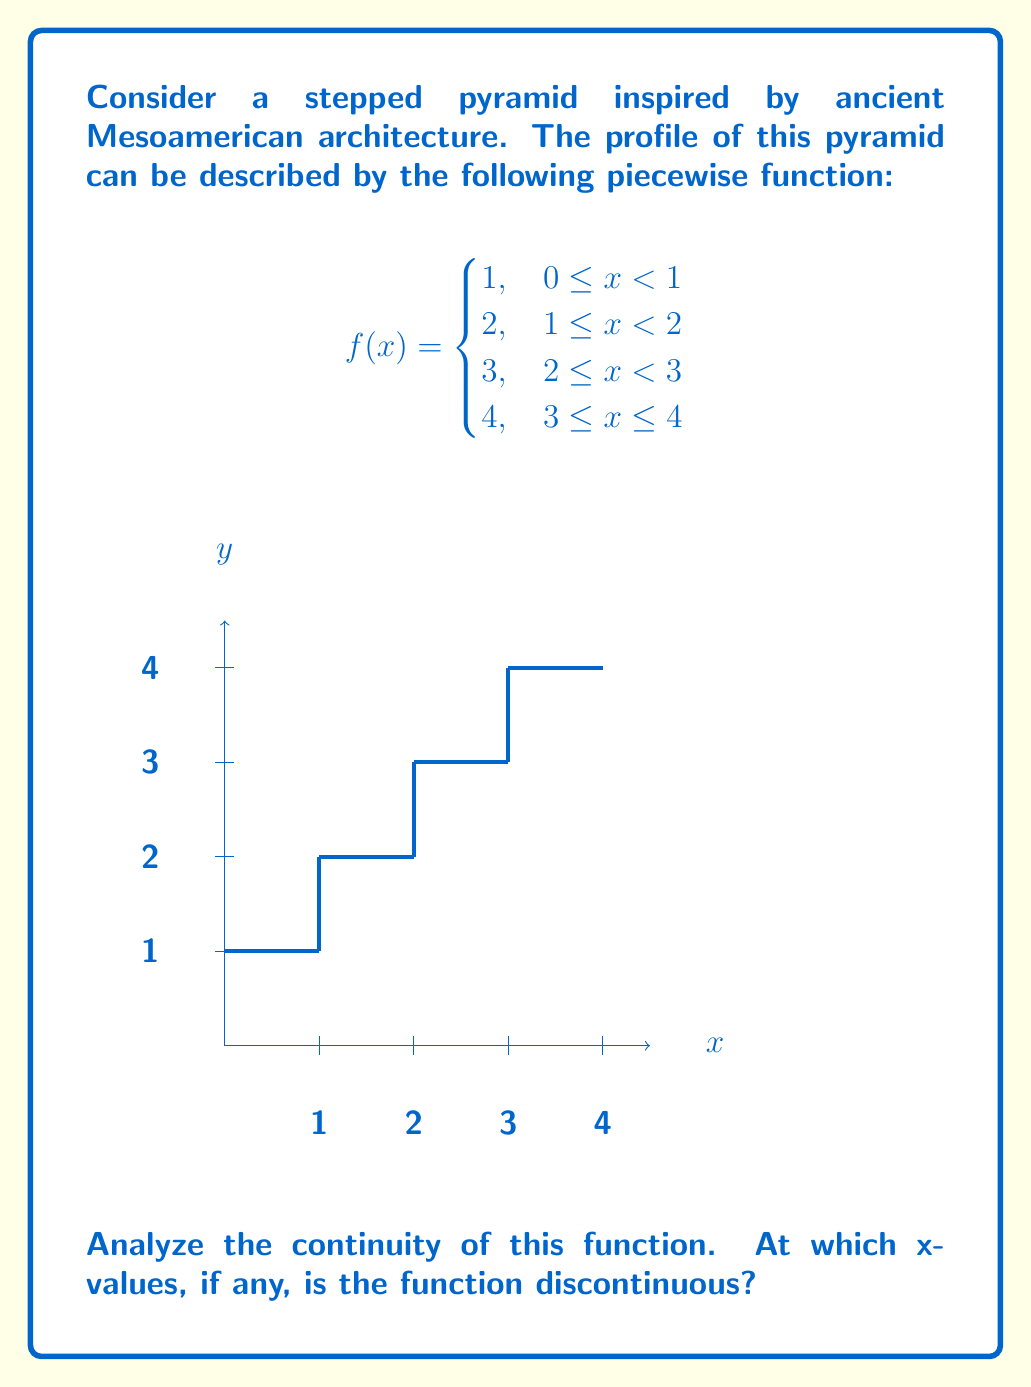Could you help me with this problem? To analyze the continuity of this piecewise function, we need to check for continuity at each of the transition points between the pieces: x = 1, x = 2, and x = 3.

A function is continuous at a point if the following three conditions are met:
1. The function is defined at that point
2. The limit of the function as we approach the point from both sides exists
3. The limit equals the function value at that point

Let's check each transition point:

1. At x = 1:
   Left limit: $\lim_{x \to 1^-} f(x) = 1$
   Right limit: $\lim_{x \to 1^+} f(x) = 2$
   Function value: $f(1) = 2$
   The left limit doesn't equal the right limit, so the function is discontinuous at x = 1.

2. At x = 2:
   Left limit: $\lim_{x \to 2^-} f(x) = 2$
   Right limit: $\lim_{x \to 2^+} f(x) = 3$
   Function value: $f(2) = 3$
   The left limit doesn't equal the right limit, so the function is discontinuous at x = 2.

3. At x = 3:
   Left limit: $\lim_{x \to 3^-} f(x) = 3$
   Right limit: $\lim_{x \to 3^+} f(x) = 4$
   Function value: $f(3) = 4$
   The left limit doesn't equal the right limit, so the function is discontinuous at x = 3.

The function is continuous on the open intervals (0,1), (1,2), (2,3), and (3,4) because it's constant on these intervals.

Therefore, the function is discontinuous at x = 1, x = 2, and x = 3.
Answer: The function is discontinuous at x = 1, 2, and 3. 